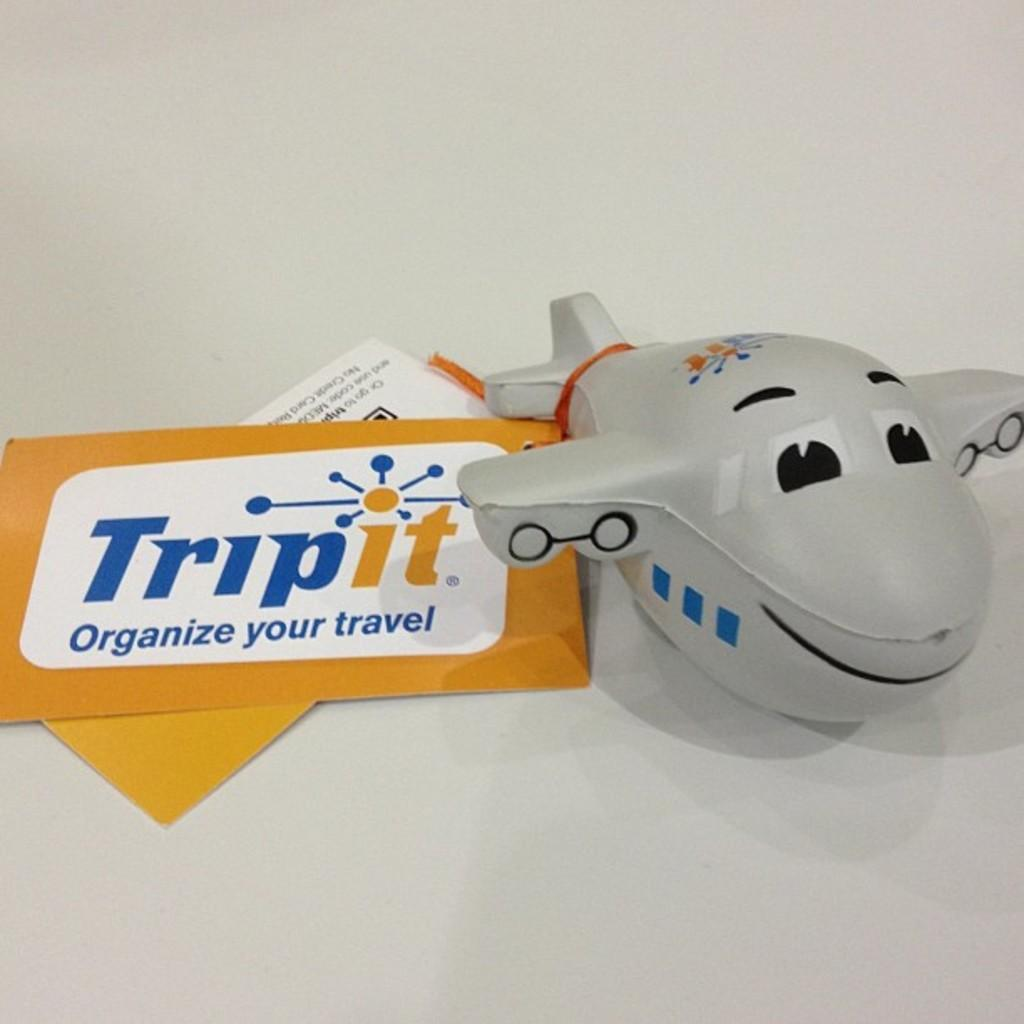<image>
Render a clear and concise summary of the photo. A small toy plane sits next to some Tripit envelopes and paperwork. 